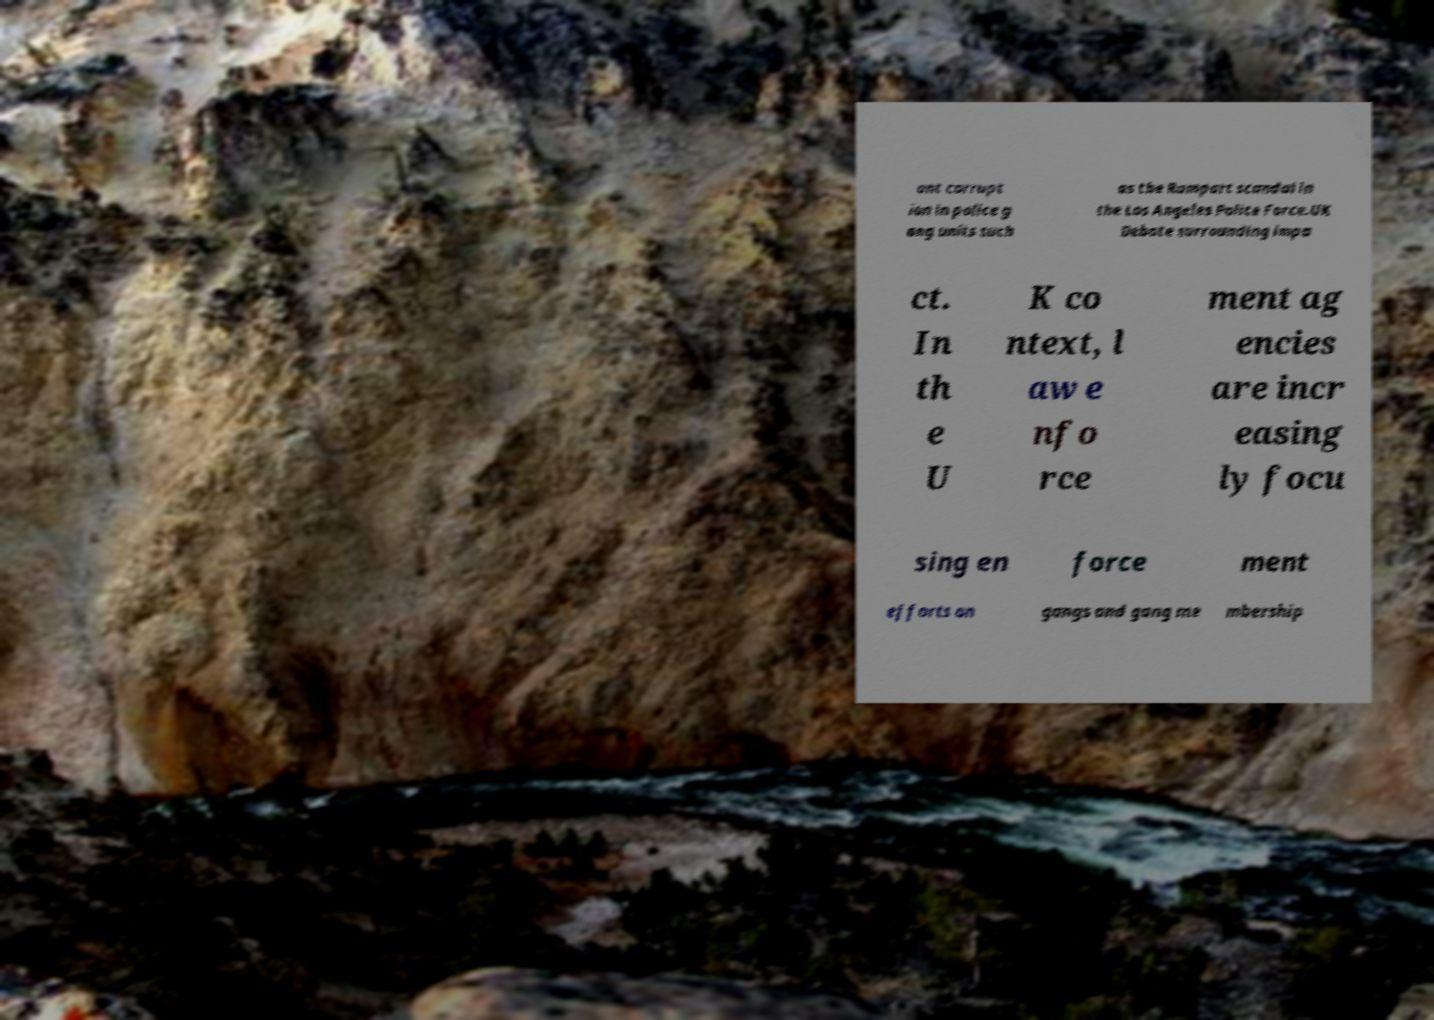Can you accurately transcribe the text from the provided image for me? ant corrupt ion in police g ang units such as the Rampart scandal in the Los Angeles Police Force.UK Debate surrounding impa ct. In th e U K co ntext, l aw e nfo rce ment ag encies are incr easing ly focu sing en force ment efforts on gangs and gang me mbership 